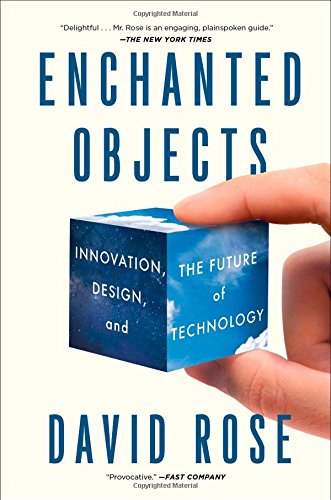What is the genre of this book? The genre of this book spans across Design, Technology, and Innovation, and delves into how our interaction with everyday objects is transformed by technology. 